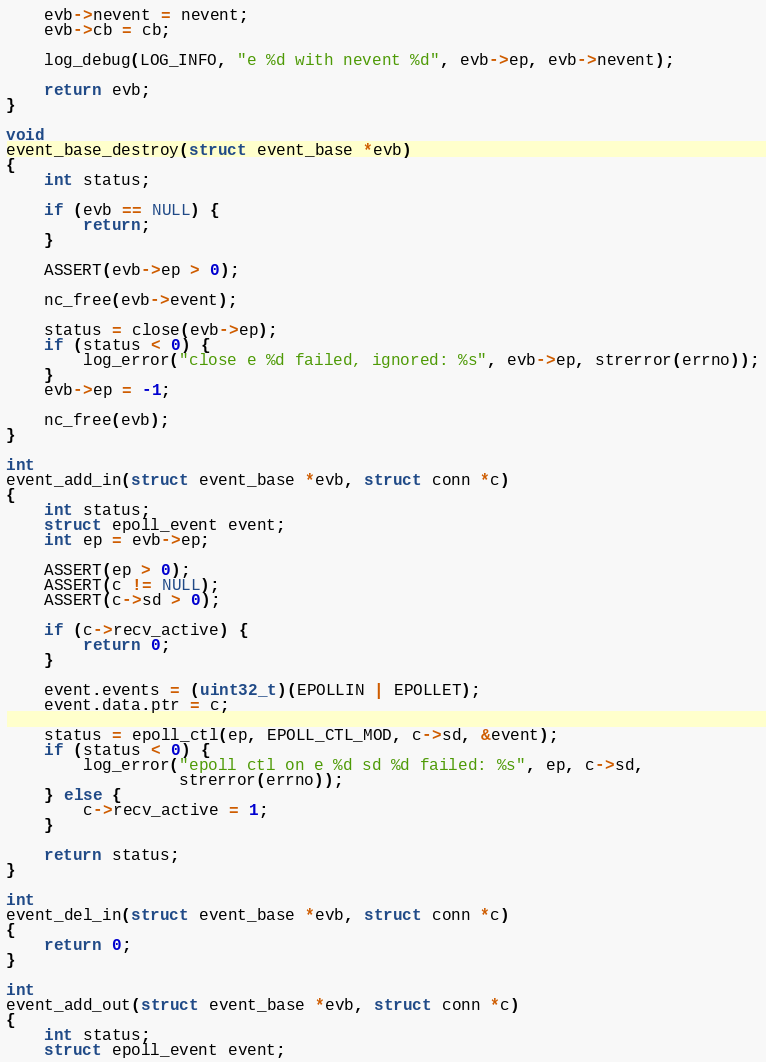Convert code to text. <code><loc_0><loc_0><loc_500><loc_500><_C_>    evb->nevent = nevent;
    evb->cb = cb;

    log_debug(LOG_INFO, "e %d with nevent %d", evb->ep, evb->nevent);

    return evb;
}

void
event_base_destroy(struct event_base *evb)
{
    int status;

    if (evb == NULL) {
        return;
    }

    ASSERT(evb->ep > 0);

    nc_free(evb->event);

    status = close(evb->ep);
    if (status < 0) {
        log_error("close e %d failed, ignored: %s", evb->ep, strerror(errno));
    }
    evb->ep = -1;

    nc_free(evb);
}

int
event_add_in(struct event_base *evb, struct conn *c)
{
    int status;
    struct epoll_event event;
    int ep = evb->ep;

    ASSERT(ep > 0);
    ASSERT(c != NULL);
    ASSERT(c->sd > 0);

    if (c->recv_active) {
        return 0;
    }

    event.events = (uint32_t)(EPOLLIN | EPOLLET);
    event.data.ptr = c;

    status = epoll_ctl(ep, EPOLL_CTL_MOD, c->sd, &event);
    if (status < 0) {
        log_error("epoll ctl on e %d sd %d failed: %s", ep, c->sd,
                  strerror(errno));
    } else {
        c->recv_active = 1;
    }

    return status;
}

int
event_del_in(struct event_base *evb, struct conn *c)
{
    return 0;
}

int
event_add_out(struct event_base *evb, struct conn *c)
{
    int status;
    struct epoll_event event;</code> 